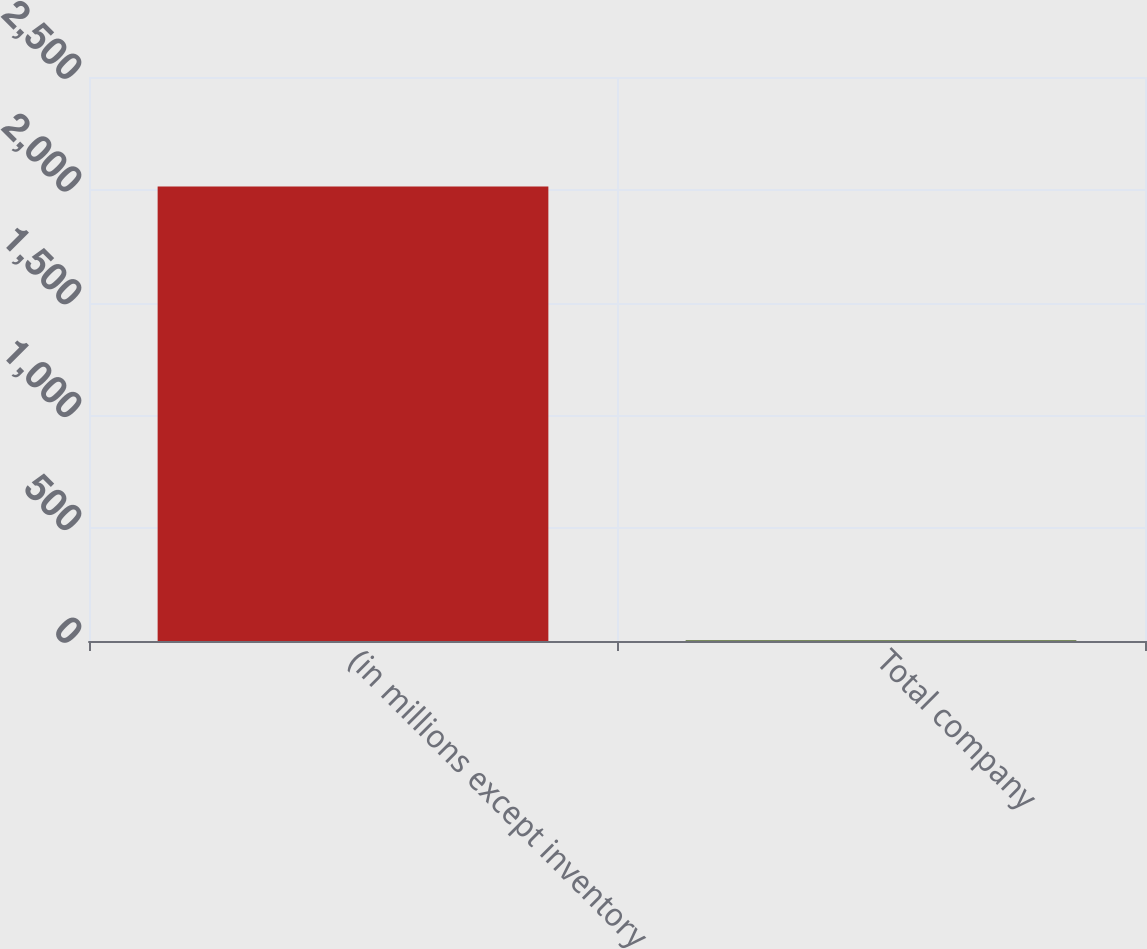<chart> <loc_0><loc_0><loc_500><loc_500><bar_chart><fcel>(in millions except inventory<fcel>Total company<nl><fcel>2015<fcel>3.6<nl></chart> 